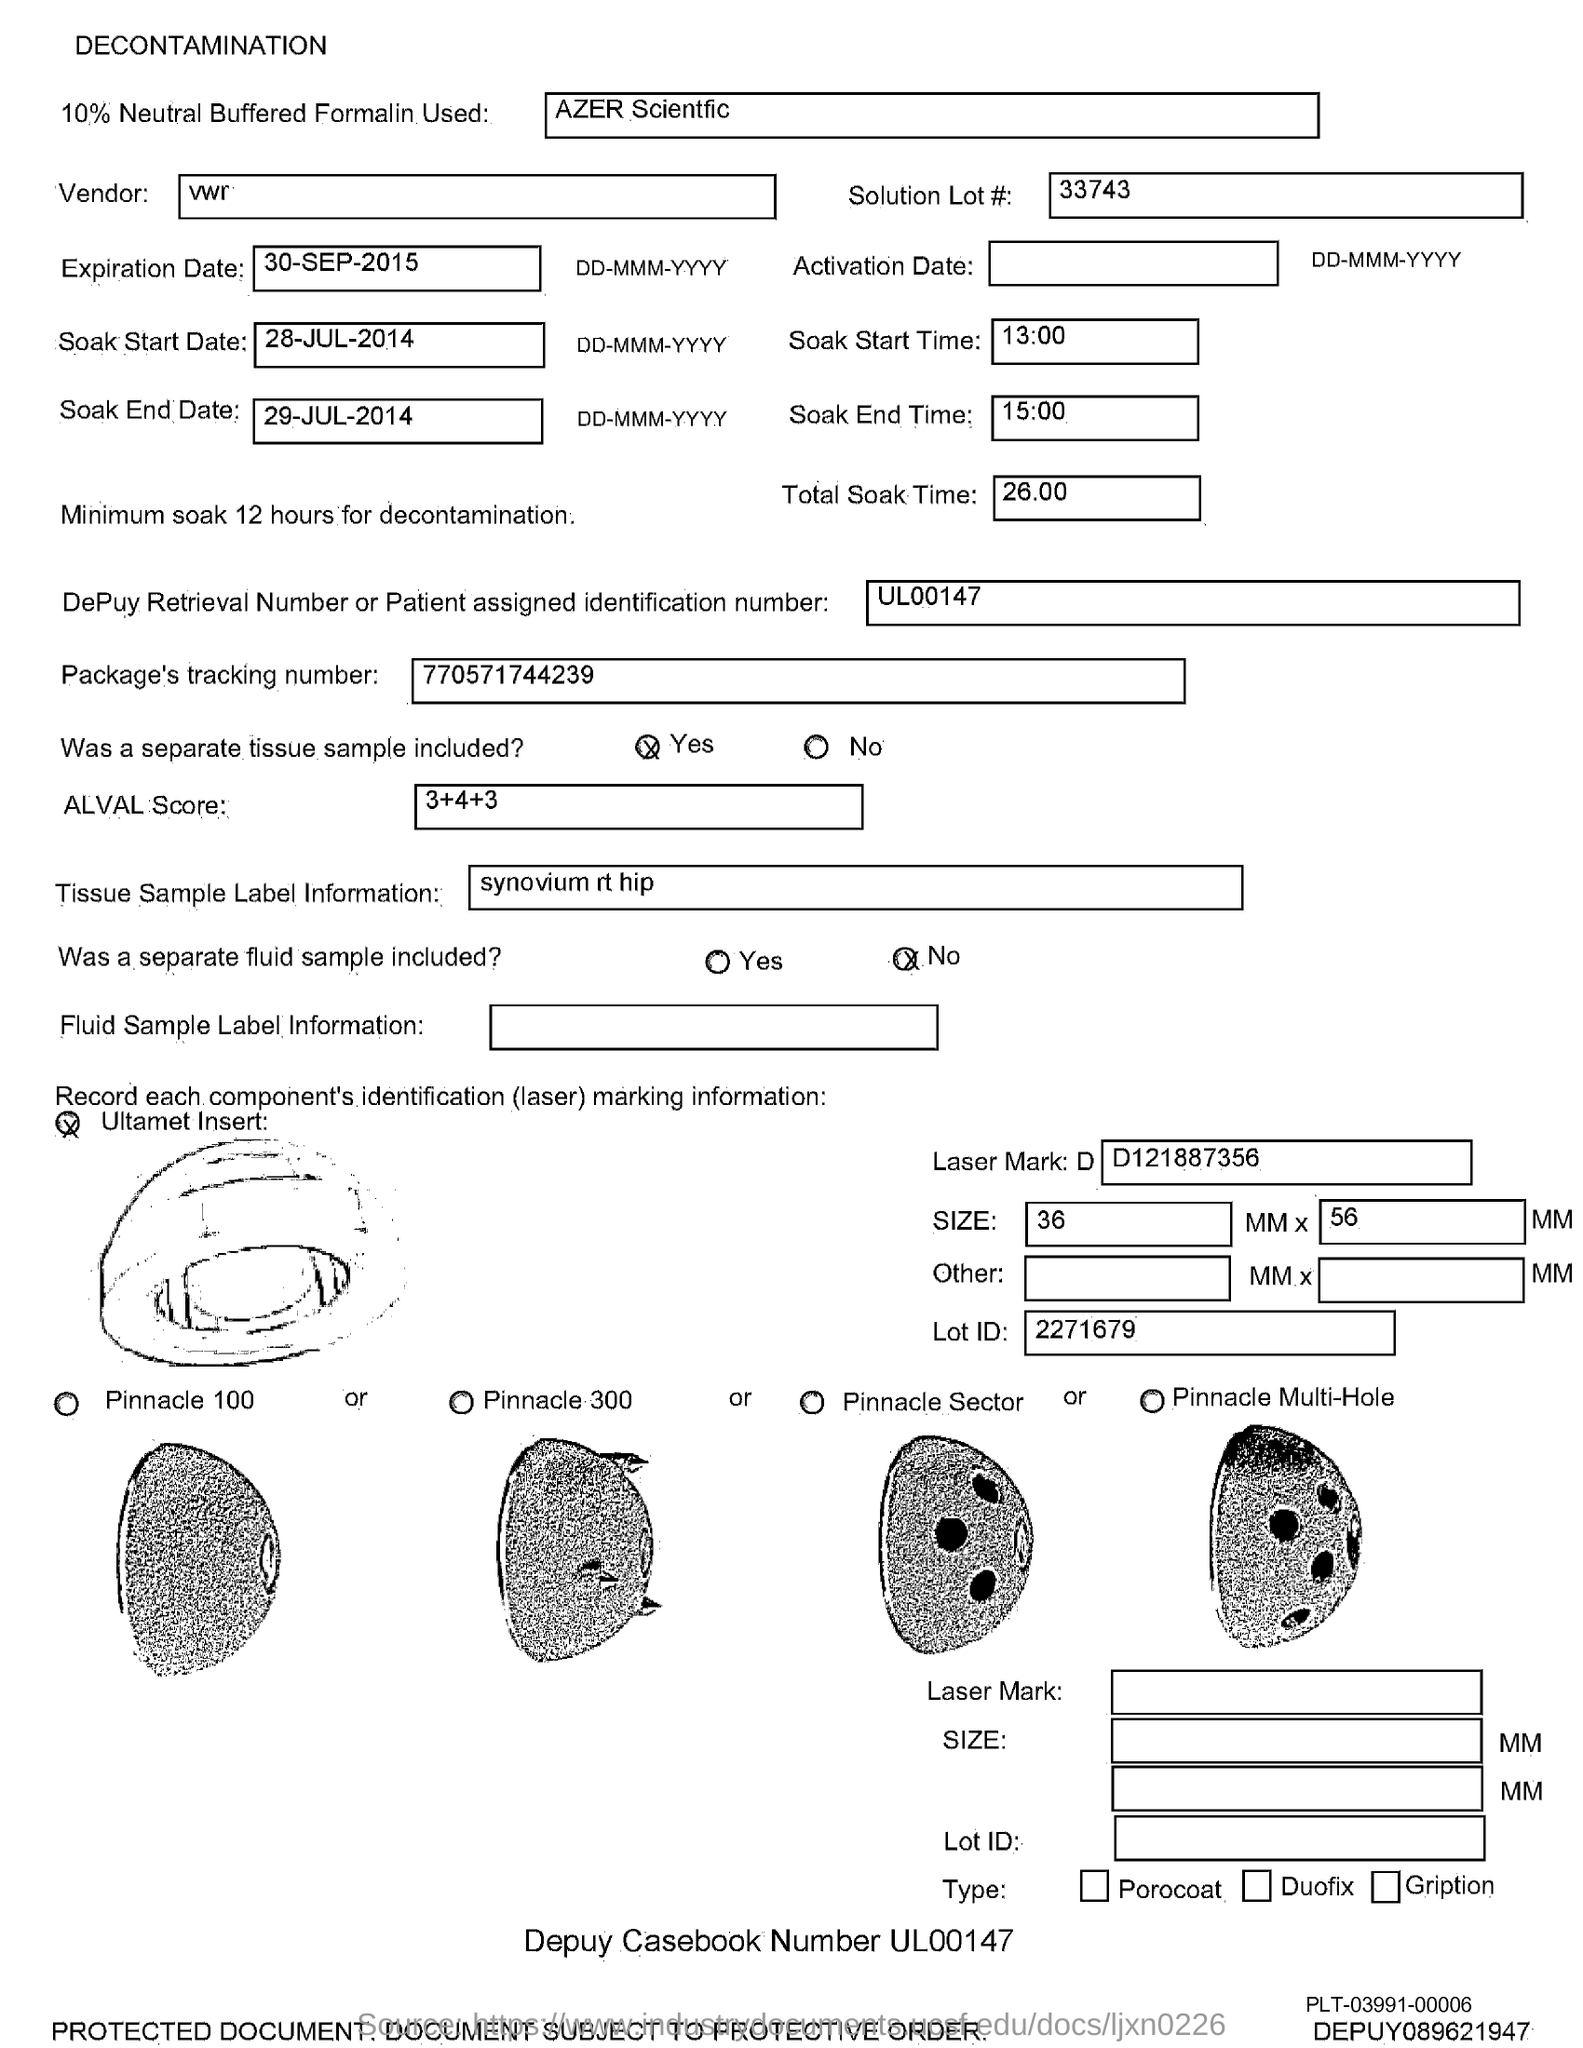What is the ALVAL Score mentioned in the document?
Ensure brevity in your answer.  3+4+3. What is the Total Soak Time?
Provide a short and direct response. 26:00. What is the Soak End Time?
Make the answer very short. 15:00. What is the Soak Start Time?
Give a very brief answer. 13:00. What is the Expiration Date?
Offer a very short reply. 30-sep-2015. What is the Soak Start Date?
Ensure brevity in your answer.  28-jul-2014. What is the Soak End Date?
Keep it short and to the point. 29-JUL-2014. 